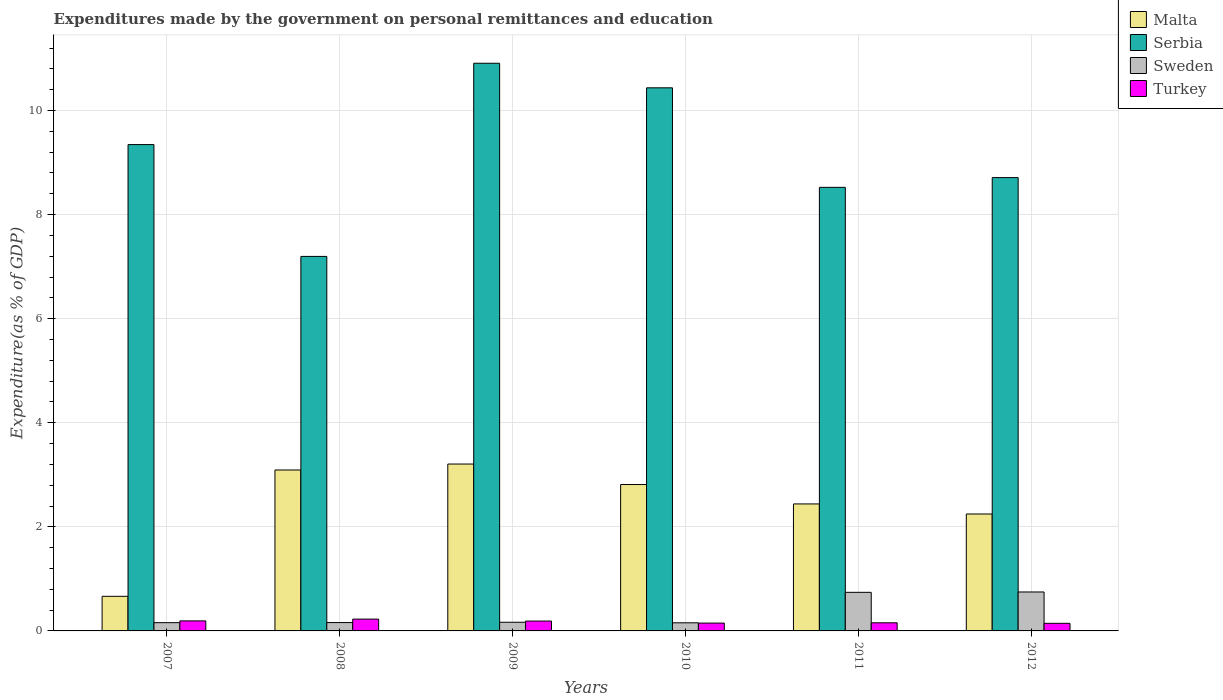How many different coloured bars are there?
Provide a short and direct response. 4. How many groups of bars are there?
Keep it short and to the point. 6. Are the number of bars per tick equal to the number of legend labels?
Your response must be concise. Yes. Are the number of bars on each tick of the X-axis equal?
Your answer should be very brief. Yes. How many bars are there on the 5th tick from the left?
Ensure brevity in your answer.  4. How many bars are there on the 1st tick from the right?
Offer a terse response. 4. What is the label of the 4th group of bars from the left?
Make the answer very short. 2010. In how many cases, is the number of bars for a given year not equal to the number of legend labels?
Your answer should be compact. 0. What is the expenditures made by the government on personal remittances and education in Turkey in 2011?
Make the answer very short. 0.16. Across all years, what is the maximum expenditures made by the government on personal remittances and education in Turkey?
Make the answer very short. 0.23. Across all years, what is the minimum expenditures made by the government on personal remittances and education in Malta?
Your answer should be compact. 0.66. In which year was the expenditures made by the government on personal remittances and education in Malta minimum?
Provide a succinct answer. 2007. What is the total expenditures made by the government on personal remittances and education in Malta in the graph?
Make the answer very short. 14.46. What is the difference between the expenditures made by the government on personal remittances and education in Serbia in 2009 and that in 2011?
Ensure brevity in your answer.  2.38. What is the difference between the expenditures made by the government on personal remittances and education in Turkey in 2011 and the expenditures made by the government on personal remittances and education in Sweden in 2010?
Ensure brevity in your answer.  0. What is the average expenditures made by the government on personal remittances and education in Malta per year?
Give a very brief answer. 2.41. In the year 2007, what is the difference between the expenditures made by the government on personal remittances and education in Turkey and expenditures made by the government on personal remittances and education in Sweden?
Give a very brief answer. 0.03. What is the ratio of the expenditures made by the government on personal remittances and education in Sweden in 2009 to that in 2012?
Offer a very short reply. 0.22. Is the difference between the expenditures made by the government on personal remittances and education in Turkey in 2007 and 2011 greater than the difference between the expenditures made by the government on personal remittances and education in Sweden in 2007 and 2011?
Make the answer very short. Yes. What is the difference between the highest and the second highest expenditures made by the government on personal remittances and education in Turkey?
Your answer should be very brief. 0.03. What is the difference between the highest and the lowest expenditures made by the government on personal remittances and education in Sweden?
Offer a very short reply. 0.59. What does the 2nd bar from the right in 2007 represents?
Make the answer very short. Sweden. Are all the bars in the graph horizontal?
Ensure brevity in your answer.  No. How many years are there in the graph?
Your answer should be very brief. 6. Does the graph contain grids?
Your answer should be very brief. Yes. Where does the legend appear in the graph?
Make the answer very short. Top right. How many legend labels are there?
Give a very brief answer. 4. What is the title of the graph?
Give a very brief answer. Expenditures made by the government on personal remittances and education. Does "Congo (Democratic)" appear as one of the legend labels in the graph?
Give a very brief answer. No. What is the label or title of the X-axis?
Offer a very short reply. Years. What is the label or title of the Y-axis?
Your response must be concise. Expenditure(as % of GDP). What is the Expenditure(as % of GDP) in Malta in 2007?
Provide a short and direct response. 0.66. What is the Expenditure(as % of GDP) in Serbia in 2007?
Your response must be concise. 9.34. What is the Expenditure(as % of GDP) of Sweden in 2007?
Your answer should be very brief. 0.16. What is the Expenditure(as % of GDP) of Turkey in 2007?
Give a very brief answer. 0.19. What is the Expenditure(as % of GDP) in Malta in 2008?
Your response must be concise. 3.09. What is the Expenditure(as % of GDP) of Serbia in 2008?
Keep it short and to the point. 7.2. What is the Expenditure(as % of GDP) in Sweden in 2008?
Keep it short and to the point. 0.16. What is the Expenditure(as % of GDP) of Turkey in 2008?
Offer a terse response. 0.23. What is the Expenditure(as % of GDP) in Malta in 2009?
Provide a short and direct response. 3.21. What is the Expenditure(as % of GDP) of Serbia in 2009?
Provide a succinct answer. 10.91. What is the Expenditure(as % of GDP) of Sweden in 2009?
Your answer should be very brief. 0.17. What is the Expenditure(as % of GDP) in Turkey in 2009?
Ensure brevity in your answer.  0.19. What is the Expenditure(as % of GDP) of Malta in 2010?
Give a very brief answer. 2.81. What is the Expenditure(as % of GDP) of Serbia in 2010?
Your response must be concise. 10.43. What is the Expenditure(as % of GDP) of Sweden in 2010?
Offer a very short reply. 0.16. What is the Expenditure(as % of GDP) in Turkey in 2010?
Keep it short and to the point. 0.15. What is the Expenditure(as % of GDP) of Malta in 2011?
Provide a short and direct response. 2.44. What is the Expenditure(as % of GDP) of Serbia in 2011?
Offer a terse response. 8.52. What is the Expenditure(as % of GDP) of Sweden in 2011?
Provide a succinct answer. 0.74. What is the Expenditure(as % of GDP) in Turkey in 2011?
Provide a short and direct response. 0.16. What is the Expenditure(as % of GDP) of Malta in 2012?
Provide a short and direct response. 2.25. What is the Expenditure(as % of GDP) in Serbia in 2012?
Ensure brevity in your answer.  8.71. What is the Expenditure(as % of GDP) in Sweden in 2012?
Provide a succinct answer. 0.75. What is the Expenditure(as % of GDP) in Turkey in 2012?
Give a very brief answer. 0.15. Across all years, what is the maximum Expenditure(as % of GDP) of Malta?
Offer a terse response. 3.21. Across all years, what is the maximum Expenditure(as % of GDP) of Serbia?
Offer a very short reply. 10.91. Across all years, what is the maximum Expenditure(as % of GDP) in Sweden?
Your answer should be very brief. 0.75. Across all years, what is the maximum Expenditure(as % of GDP) in Turkey?
Your response must be concise. 0.23. Across all years, what is the minimum Expenditure(as % of GDP) in Malta?
Provide a short and direct response. 0.66. Across all years, what is the minimum Expenditure(as % of GDP) in Serbia?
Give a very brief answer. 7.2. Across all years, what is the minimum Expenditure(as % of GDP) in Sweden?
Make the answer very short. 0.16. Across all years, what is the minimum Expenditure(as % of GDP) of Turkey?
Offer a very short reply. 0.15. What is the total Expenditure(as % of GDP) in Malta in the graph?
Offer a very short reply. 14.46. What is the total Expenditure(as % of GDP) of Serbia in the graph?
Your response must be concise. 55.11. What is the total Expenditure(as % of GDP) of Sweden in the graph?
Keep it short and to the point. 2.13. What is the total Expenditure(as % of GDP) of Turkey in the graph?
Offer a very short reply. 1.06. What is the difference between the Expenditure(as % of GDP) in Malta in 2007 and that in 2008?
Make the answer very short. -2.43. What is the difference between the Expenditure(as % of GDP) of Serbia in 2007 and that in 2008?
Offer a very short reply. 2.15. What is the difference between the Expenditure(as % of GDP) in Sweden in 2007 and that in 2008?
Provide a succinct answer. -0. What is the difference between the Expenditure(as % of GDP) in Turkey in 2007 and that in 2008?
Keep it short and to the point. -0.03. What is the difference between the Expenditure(as % of GDP) in Malta in 2007 and that in 2009?
Your answer should be very brief. -2.54. What is the difference between the Expenditure(as % of GDP) in Serbia in 2007 and that in 2009?
Keep it short and to the point. -1.56. What is the difference between the Expenditure(as % of GDP) in Sweden in 2007 and that in 2009?
Provide a short and direct response. -0.01. What is the difference between the Expenditure(as % of GDP) of Turkey in 2007 and that in 2009?
Make the answer very short. 0. What is the difference between the Expenditure(as % of GDP) of Malta in 2007 and that in 2010?
Your response must be concise. -2.15. What is the difference between the Expenditure(as % of GDP) of Serbia in 2007 and that in 2010?
Your answer should be compact. -1.09. What is the difference between the Expenditure(as % of GDP) of Sweden in 2007 and that in 2010?
Your response must be concise. 0. What is the difference between the Expenditure(as % of GDP) of Turkey in 2007 and that in 2010?
Make the answer very short. 0.04. What is the difference between the Expenditure(as % of GDP) in Malta in 2007 and that in 2011?
Your answer should be very brief. -1.77. What is the difference between the Expenditure(as % of GDP) of Serbia in 2007 and that in 2011?
Your answer should be very brief. 0.82. What is the difference between the Expenditure(as % of GDP) in Sweden in 2007 and that in 2011?
Provide a short and direct response. -0.58. What is the difference between the Expenditure(as % of GDP) in Turkey in 2007 and that in 2011?
Offer a terse response. 0.04. What is the difference between the Expenditure(as % of GDP) of Malta in 2007 and that in 2012?
Keep it short and to the point. -1.58. What is the difference between the Expenditure(as % of GDP) of Serbia in 2007 and that in 2012?
Your response must be concise. 0.63. What is the difference between the Expenditure(as % of GDP) in Sweden in 2007 and that in 2012?
Your response must be concise. -0.59. What is the difference between the Expenditure(as % of GDP) of Turkey in 2007 and that in 2012?
Provide a short and direct response. 0.05. What is the difference between the Expenditure(as % of GDP) of Malta in 2008 and that in 2009?
Offer a very short reply. -0.11. What is the difference between the Expenditure(as % of GDP) in Serbia in 2008 and that in 2009?
Provide a succinct answer. -3.71. What is the difference between the Expenditure(as % of GDP) of Sweden in 2008 and that in 2009?
Provide a succinct answer. -0.01. What is the difference between the Expenditure(as % of GDP) in Turkey in 2008 and that in 2009?
Offer a terse response. 0.04. What is the difference between the Expenditure(as % of GDP) of Malta in 2008 and that in 2010?
Provide a short and direct response. 0.28. What is the difference between the Expenditure(as % of GDP) of Serbia in 2008 and that in 2010?
Make the answer very short. -3.24. What is the difference between the Expenditure(as % of GDP) of Sweden in 2008 and that in 2010?
Offer a terse response. 0. What is the difference between the Expenditure(as % of GDP) of Turkey in 2008 and that in 2010?
Keep it short and to the point. 0.08. What is the difference between the Expenditure(as % of GDP) in Malta in 2008 and that in 2011?
Offer a very short reply. 0.65. What is the difference between the Expenditure(as % of GDP) in Serbia in 2008 and that in 2011?
Your answer should be compact. -1.33. What is the difference between the Expenditure(as % of GDP) in Sweden in 2008 and that in 2011?
Offer a very short reply. -0.58. What is the difference between the Expenditure(as % of GDP) in Turkey in 2008 and that in 2011?
Give a very brief answer. 0.07. What is the difference between the Expenditure(as % of GDP) of Malta in 2008 and that in 2012?
Your answer should be compact. 0.85. What is the difference between the Expenditure(as % of GDP) of Serbia in 2008 and that in 2012?
Give a very brief answer. -1.51. What is the difference between the Expenditure(as % of GDP) in Sweden in 2008 and that in 2012?
Give a very brief answer. -0.59. What is the difference between the Expenditure(as % of GDP) of Turkey in 2008 and that in 2012?
Give a very brief answer. 0.08. What is the difference between the Expenditure(as % of GDP) in Malta in 2009 and that in 2010?
Ensure brevity in your answer.  0.39. What is the difference between the Expenditure(as % of GDP) in Serbia in 2009 and that in 2010?
Provide a short and direct response. 0.47. What is the difference between the Expenditure(as % of GDP) of Sweden in 2009 and that in 2010?
Provide a short and direct response. 0.01. What is the difference between the Expenditure(as % of GDP) of Turkey in 2009 and that in 2010?
Ensure brevity in your answer.  0.04. What is the difference between the Expenditure(as % of GDP) of Malta in 2009 and that in 2011?
Make the answer very short. 0.77. What is the difference between the Expenditure(as % of GDP) in Serbia in 2009 and that in 2011?
Offer a very short reply. 2.38. What is the difference between the Expenditure(as % of GDP) of Sweden in 2009 and that in 2011?
Provide a short and direct response. -0.58. What is the difference between the Expenditure(as % of GDP) in Turkey in 2009 and that in 2011?
Offer a very short reply. 0.03. What is the difference between the Expenditure(as % of GDP) in Malta in 2009 and that in 2012?
Provide a short and direct response. 0.96. What is the difference between the Expenditure(as % of GDP) of Serbia in 2009 and that in 2012?
Your answer should be compact. 2.2. What is the difference between the Expenditure(as % of GDP) in Sweden in 2009 and that in 2012?
Your answer should be compact. -0.58. What is the difference between the Expenditure(as % of GDP) in Turkey in 2009 and that in 2012?
Make the answer very short. 0.04. What is the difference between the Expenditure(as % of GDP) in Malta in 2010 and that in 2011?
Make the answer very short. 0.37. What is the difference between the Expenditure(as % of GDP) in Serbia in 2010 and that in 2011?
Your answer should be very brief. 1.91. What is the difference between the Expenditure(as % of GDP) in Sweden in 2010 and that in 2011?
Provide a short and direct response. -0.59. What is the difference between the Expenditure(as % of GDP) in Turkey in 2010 and that in 2011?
Keep it short and to the point. -0.01. What is the difference between the Expenditure(as % of GDP) of Malta in 2010 and that in 2012?
Provide a short and direct response. 0.57. What is the difference between the Expenditure(as % of GDP) in Serbia in 2010 and that in 2012?
Give a very brief answer. 1.72. What is the difference between the Expenditure(as % of GDP) of Sweden in 2010 and that in 2012?
Your response must be concise. -0.59. What is the difference between the Expenditure(as % of GDP) of Turkey in 2010 and that in 2012?
Your answer should be compact. 0. What is the difference between the Expenditure(as % of GDP) of Malta in 2011 and that in 2012?
Offer a terse response. 0.19. What is the difference between the Expenditure(as % of GDP) in Serbia in 2011 and that in 2012?
Your response must be concise. -0.19. What is the difference between the Expenditure(as % of GDP) of Sweden in 2011 and that in 2012?
Make the answer very short. -0.01. What is the difference between the Expenditure(as % of GDP) of Turkey in 2011 and that in 2012?
Make the answer very short. 0.01. What is the difference between the Expenditure(as % of GDP) in Malta in 2007 and the Expenditure(as % of GDP) in Serbia in 2008?
Provide a succinct answer. -6.53. What is the difference between the Expenditure(as % of GDP) of Malta in 2007 and the Expenditure(as % of GDP) of Sweden in 2008?
Your answer should be compact. 0.5. What is the difference between the Expenditure(as % of GDP) in Malta in 2007 and the Expenditure(as % of GDP) in Turkey in 2008?
Your answer should be very brief. 0.44. What is the difference between the Expenditure(as % of GDP) in Serbia in 2007 and the Expenditure(as % of GDP) in Sweden in 2008?
Make the answer very short. 9.18. What is the difference between the Expenditure(as % of GDP) of Serbia in 2007 and the Expenditure(as % of GDP) of Turkey in 2008?
Your answer should be compact. 9.12. What is the difference between the Expenditure(as % of GDP) in Sweden in 2007 and the Expenditure(as % of GDP) in Turkey in 2008?
Make the answer very short. -0.07. What is the difference between the Expenditure(as % of GDP) of Malta in 2007 and the Expenditure(as % of GDP) of Serbia in 2009?
Your response must be concise. -10.24. What is the difference between the Expenditure(as % of GDP) of Malta in 2007 and the Expenditure(as % of GDP) of Sweden in 2009?
Your answer should be very brief. 0.5. What is the difference between the Expenditure(as % of GDP) in Malta in 2007 and the Expenditure(as % of GDP) in Turkey in 2009?
Ensure brevity in your answer.  0.48. What is the difference between the Expenditure(as % of GDP) in Serbia in 2007 and the Expenditure(as % of GDP) in Sweden in 2009?
Your response must be concise. 9.18. What is the difference between the Expenditure(as % of GDP) of Serbia in 2007 and the Expenditure(as % of GDP) of Turkey in 2009?
Your answer should be very brief. 9.15. What is the difference between the Expenditure(as % of GDP) in Sweden in 2007 and the Expenditure(as % of GDP) in Turkey in 2009?
Keep it short and to the point. -0.03. What is the difference between the Expenditure(as % of GDP) of Malta in 2007 and the Expenditure(as % of GDP) of Serbia in 2010?
Your answer should be very brief. -9.77. What is the difference between the Expenditure(as % of GDP) in Malta in 2007 and the Expenditure(as % of GDP) in Sweden in 2010?
Keep it short and to the point. 0.51. What is the difference between the Expenditure(as % of GDP) of Malta in 2007 and the Expenditure(as % of GDP) of Turkey in 2010?
Your response must be concise. 0.51. What is the difference between the Expenditure(as % of GDP) of Serbia in 2007 and the Expenditure(as % of GDP) of Sweden in 2010?
Your answer should be compact. 9.19. What is the difference between the Expenditure(as % of GDP) in Serbia in 2007 and the Expenditure(as % of GDP) in Turkey in 2010?
Provide a short and direct response. 9.19. What is the difference between the Expenditure(as % of GDP) of Sweden in 2007 and the Expenditure(as % of GDP) of Turkey in 2010?
Ensure brevity in your answer.  0.01. What is the difference between the Expenditure(as % of GDP) in Malta in 2007 and the Expenditure(as % of GDP) in Serbia in 2011?
Keep it short and to the point. -7.86. What is the difference between the Expenditure(as % of GDP) in Malta in 2007 and the Expenditure(as % of GDP) in Sweden in 2011?
Offer a very short reply. -0.08. What is the difference between the Expenditure(as % of GDP) in Malta in 2007 and the Expenditure(as % of GDP) in Turkey in 2011?
Keep it short and to the point. 0.51. What is the difference between the Expenditure(as % of GDP) in Serbia in 2007 and the Expenditure(as % of GDP) in Sweden in 2011?
Provide a succinct answer. 8.6. What is the difference between the Expenditure(as % of GDP) of Serbia in 2007 and the Expenditure(as % of GDP) of Turkey in 2011?
Give a very brief answer. 9.19. What is the difference between the Expenditure(as % of GDP) of Sweden in 2007 and the Expenditure(as % of GDP) of Turkey in 2011?
Offer a terse response. 0. What is the difference between the Expenditure(as % of GDP) in Malta in 2007 and the Expenditure(as % of GDP) in Serbia in 2012?
Make the answer very short. -8.04. What is the difference between the Expenditure(as % of GDP) of Malta in 2007 and the Expenditure(as % of GDP) of Sweden in 2012?
Give a very brief answer. -0.08. What is the difference between the Expenditure(as % of GDP) of Malta in 2007 and the Expenditure(as % of GDP) of Turkey in 2012?
Provide a succinct answer. 0.52. What is the difference between the Expenditure(as % of GDP) in Serbia in 2007 and the Expenditure(as % of GDP) in Sweden in 2012?
Keep it short and to the point. 8.6. What is the difference between the Expenditure(as % of GDP) in Serbia in 2007 and the Expenditure(as % of GDP) in Turkey in 2012?
Provide a succinct answer. 9.2. What is the difference between the Expenditure(as % of GDP) in Sweden in 2007 and the Expenditure(as % of GDP) in Turkey in 2012?
Keep it short and to the point. 0.01. What is the difference between the Expenditure(as % of GDP) in Malta in 2008 and the Expenditure(as % of GDP) in Serbia in 2009?
Offer a terse response. -7.82. What is the difference between the Expenditure(as % of GDP) in Malta in 2008 and the Expenditure(as % of GDP) in Sweden in 2009?
Offer a terse response. 2.93. What is the difference between the Expenditure(as % of GDP) in Malta in 2008 and the Expenditure(as % of GDP) in Turkey in 2009?
Give a very brief answer. 2.9. What is the difference between the Expenditure(as % of GDP) of Serbia in 2008 and the Expenditure(as % of GDP) of Sweden in 2009?
Keep it short and to the point. 7.03. What is the difference between the Expenditure(as % of GDP) in Serbia in 2008 and the Expenditure(as % of GDP) in Turkey in 2009?
Offer a very short reply. 7.01. What is the difference between the Expenditure(as % of GDP) of Sweden in 2008 and the Expenditure(as % of GDP) of Turkey in 2009?
Your response must be concise. -0.03. What is the difference between the Expenditure(as % of GDP) in Malta in 2008 and the Expenditure(as % of GDP) in Serbia in 2010?
Offer a terse response. -7.34. What is the difference between the Expenditure(as % of GDP) in Malta in 2008 and the Expenditure(as % of GDP) in Sweden in 2010?
Offer a very short reply. 2.94. What is the difference between the Expenditure(as % of GDP) in Malta in 2008 and the Expenditure(as % of GDP) in Turkey in 2010?
Provide a short and direct response. 2.94. What is the difference between the Expenditure(as % of GDP) in Serbia in 2008 and the Expenditure(as % of GDP) in Sweden in 2010?
Give a very brief answer. 7.04. What is the difference between the Expenditure(as % of GDP) of Serbia in 2008 and the Expenditure(as % of GDP) of Turkey in 2010?
Offer a very short reply. 7.05. What is the difference between the Expenditure(as % of GDP) in Malta in 2008 and the Expenditure(as % of GDP) in Serbia in 2011?
Your answer should be compact. -5.43. What is the difference between the Expenditure(as % of GDP) of Malta in 2008 and the Expenditure(as % of GDP) of Sweden in 2011?
Provide a succinct answer. 2.35. What is the difference between the Expenditure(as % of GDP) in Malta in 2008 and the Expenditure(as % of GDP) in Turkey in 2011?
Your response must be concise. 2.94. What is the difference between the Expenditure(as % of GDP) in Serbia in 2008 and the Expenditure(as % of GDP) in Sweden in 2011?
Give a very brief answer. 6.45. What is the difference between the Expenditure(as % of GDP) in Serbia in 2008 and the Expenditure(as % of GDP) in Turkey in 2011?
Make the answer very short. 7.04. What is the difference between the Expenditure(as % of GDP) of Sweden in 2008 and the Expenditure(as % of GDP) of Turkey in 2011?
Your answer should be very brief. 0. What is the difference between the Expenditure(as % of GDP) in Malta in 2008 and the Expenditure(as % of GDP) in Serbia in 2012?
Make the answer very short. -5.62. What is the difference between the Expenditure(as % of GDP) of Malta in 2008 and the Expenditure(as % of GDP) of Sweden in 2012?
Your answer should be compact. 2.34. What is the difference between the Expenditure(as % of GDP) in Malta in 2008 and the Expenditure(as % of GDP) in Turkey in 2012?
Keep it short and to the point. 2.95. What is the difference between the Expenditure(as % of GDP) of Serbia in 2008 and the Expenditure(as % of GDP) of Sweden in 2012?
Keep it short and to the point. 6.45. What is the difference between the Expenditure(as % of GDP) in Serbia in 2008 and the Expenditure(as % of GDP) in Turkey in 2012?
Make the answer very short. 7.05. What is the difference between the Expenditure(as % of GDP) in Sweden in 2008 and the Expenditure(as % of GDP) in Turkey in 2012?
Keep it short and to the point. 0.01. What is the difference between the Expenditure(as % of GDP) of Malta in 2009 and the Expenditure(as % of GDP) of Serbia in 2010?
Provide a short and direct response. -7.23. What is the difference between the Expenditure(as % of GDP) of Malta in 2009 and the Expenditure(as % of GDP) of Sweden in 2010?
Give a very brief answer. 3.05. What is the difference between the Expenditure(as % of GDP) in Malta in 2009 and the Expenditure(as % of GDP) in Turkey in 2010?
Provide a short and direct response. 3.06. What is the difference between the Expenditure(as % of GDP) in Serbia in 2009 and the Expenditure(as % of GDP) in Sweden in 2010?
Give a very brief answer. 10.75. What is the difference between the Expenditure(as % of GDP) of Serbia in 2009 and the Expenditure(as % of GDP) of Turkey in 2010?
Make the answer very short. 10.76. What is the difference between the Expenditure(as % of GDP) of Sweden in 2009 and the Expenditure(as % of GDP) of Turkey in 2010?
Offer a very short reply. 0.02. What is the difference between the Expenditure(as % of GDP) of Malta in 2009 and the Expenditure(as % of GDP) of Serbia in 2011?
Keep it short and to the point. -5.32. What is the difference between the Expenditure(as % of GDP) of Malta in 2009 and the Expenditure(as % of GDP) of Sweden in 2011?
Make the answer very short. 2.46. What is the difference between the Expenditure(as % of GDP) of Malta in 2009 and the Expenditure(as % of GDP) of Turkey in 2011?
Make the answer very short. 3.05. What is the difference between the Expenditure(as % of GDP) in Serbia in 2009 and the Expenditure(as % of GDP) in Sweden in 2011?
Offer a terse response. 10.17. What is the difference between the Expenditure(as % of GDP) in Serbia in 2009 and the Expenditure(as % of GDP) in Turkey in 2011?
Offer a very short reply. 10.75. What is the difference between the Expenditure(as % of GDP) of Sweden in 2009 and the Expenditure(as % of GDP) of Turkey in 2011?
Your response must be concise. 0.01. What is the difference between the Expenditure(as % of GDP) in Malta in 2009 and the Expenditure(as % of GDP) in Serbia in 2012?
Offer a very short reply. -5.5. What is the difference between the Expenditure(as % of GDP) in Malta in 2009 and the Expenditure(as % of GDP) in Sweden in 2012?
Keep it short and to the point. 2.46. What is the difference between the Expenditure(as % of GDP) in Malta in 2009 and the Expenditure(as % of GDP) in Turkey in 2012?
Keep it short and to the point. 3.06. What is the difference between the Expenditure(as % of GDP) of Serbia in 2009 and the Expenditure(as % of GDP) of Sweden in 2012?
Your response must be concise. 10.16. What is the difference between the Expenditure(as % of GDP) of Serbia in 2009 and the Expenditure(as % of GDP) of Turkey in 2012?
Provide a short and direct response. 10.76. What is the difference between the Expenditure(as % of GDP) in Sweden in 2009 and the Expenditure(as % of GDP) in Turkey in 2012?
Your response must be concise. 0.02. What is the difference between the Expenditure(as % of GDP) of Malta in 2010 and the Expenditure(as % of GDP) of Serbia in 2011?
Offer a very short reply. -5.71. What is the difference between the Expenditure(as % of GDP) of Malta in 2010 and the Expenditure(as % of GDP) of Sweden in 2011?
Offer a terse response. 2.07. What is the difference between the Expenditure(as % of GDP) in Malta in 2010 and the Expenditure(as % of GDP) in Turkey in 2011?
Keep it short and to the point. 2.66. What is the difference between the Expenditure(as % of GDP) in Serbia in 2010 and the Expenditure(as % of GDP) in Sweden in 2011?
Ensure brevity in your answer.  9.69. What is the difference between the Expenditure(as % of GDP) in Serbia in 2010 and the Expenditure(as % of GDP) in Turkey in 2011?
Offer a terse response. 10.28. What is the difference between the Expenditure(as % of GDP) of Sweden in 2010 and the Expenditure(as % of GDP) of Turkey in 2011?
Provide a short and direct response. -0. What is the difference between the Expenditure(as % of GDP) in Malta in 2010 and the Expenditure(as % of GDP) in Serbia in 2012?
Offer a terse response. -5.9. What is the difference between the Expenditure(as % of GDP) of Malta in 2010 and the Expenditure(as % of GDP) of Sweden in 2012?
Offer a terse response. 2.06. What is the difference between the Expenditure(as % of GDP) of Malta in 2010 and the Expenditure(as % of GDP) of Turkey in 2012?
Keep it short and to the point. 2.67. What is the difference between the Expenditure(as % of GDP) of Serbia in 2010 and the Expenditure(as % of GDP) of Sweden in 2012?
Give a very brief answer. 9.69. What is the difference between the Expenditure(as % of GDP) of Serbia in 2010 and the Expenditure(as % of GDP) of Turkey in 2012?
Provide a succinct answer. 10.29. What is the difference between the Expenditure(as % of GDP) in Sweden in 2010 and the Expenditure(as % of GDP) in Turkey in 2012?
Provide a short and direct response. 0.01. What is the difference between the Expenditure(as % of GDP) in Malta in 2011 and the Expenditure(as % of GDP) in Serbia in 2012?
Give a very brief answer. -6.27. What is the difference between the Expenditure(as % of GDP) in Malta in 2011 and the Expenditure(as % of GDP) in Sweden in 2012?
Offer a terse response. 1.69. What is the difference between the Expenditure(as % of GDP) in Malta in 2011 and the Expenditure(as % of GDP) in Turkey in 2012?
Ensure brevity in your answer.  2.29. What is the difference between the Expenditure(as % of GDP) in Serbia in 2011 and the Expenditure(as % of GDP) in Sweden in 2012?
Make the answer very short. 7.77. What is the difference between the Expenditure(as % of GDP) of Serbia in 2011 and the Expenditure(as % of GDP) of Turkey in 2012?
Offer a very short reply. 8.38. What is the difference between the Expenditure(as % of GDP) of Sweden in 2011 and the Expenditure(as % of GDP) of Turkey in 2012?
Provide a short and direct response. 0.6. What is the average Expenditure(as % of GDP) of Malta per year?
Keep it short and to the point. 2.41. What is the average Expenditure(as % of GDP) in Serbia per year?
Your answer should be compact. 9.19. What is the average Expenditure(as % of GDP) of Sweden per year?
Make the answer very short. 0.36. What is the average Expenditure(as % of GDP) of Turkey per year?
Make the answer very short. 0.18. In the year 2007, what is the difference between the Expenditure(as % of GDP) in Malta and Expenditure(as % of GDP) in Serbia?
Keep it short and to the point. -8.68. In the year 2007, what is the difference between the Expenditure(as % of GDP) of Malta and Expenditure(as % of GDP) of Sweden?
Your answer should be compact. 0.51. In the year 2007, what is the difference between the Expenditure(as % of GDP) in Malta and Expenditure(as % of GDP) in Turkey?
Offer a terse response. 0.47. In the year 2007, what is the difference between the Expenditure(as % of GDP) of Serbia and Expenditure(as % of GDP) of Sweden?
Provide a short and direct response. 9.19. In the year 2007, what is the difference between the Expenditure(as % of GDP) of Serbia and Expenditure(as % of GDP) of Turkey?
Your response must be concise. 9.15. In the year 2007, what is the difference between the Expenditure(as % of GDP) in Sweden and Expenditure(as % of GDP) in Turkey?
Provide a succinct answer. -0.03. In the year 2008, what is the difference between the Expenditure(as % of GDP) of Malta and Expenditure(as % of GDP) of Serbia?
Provide a succinct answer. -4.1. In the year 2008, what is the difference between the Expenditure(as % of GDP) in Malta and Expenditure(as % of GDP) in Sweden?
Provide a short and direct response. 2.93. In the year 2008, what is the difference between the Expenditure(as % of GDP) in Malta and Expenditure(as % of GDP) in Turkey?
Give a very brief answer. 2.86. In the year 2008, what is the difference between the Expenditure(as % of GDP) of Serbia and Expenditure(as % of GDP) of Sweden?
Provide a succinct answer. 7.04. In the year 2008, what is the difference between the Expenditure(as % of GDP) of Serbia and Expenditure(as % of GDP) of Turkey?
Your answer should be compact. 6.97. In the year 2008, what is the difference between the Expenditure(as % of GDP) in Sweden and Expenditure(as % of GDP) in Turkey?
Provide a short and direct response. -0.07. In the year 2009, what is the difference between the Expenditure(as % of GDP) of Malta and Expenditure(as % of GDP) of Serbia?
Make the answer very short. -7.7. In the year 2009, what is the difference between the Expenditure(as % of GDP) of Malta and Expenditure(as % of GDP) of Sweden?
Provide a succinct answer. 3.04. In the year 2009, what is the difference between the Expenditure(as % of GDP) in Malta and Expenditure(as % of GDP) in Turkey?
Make the answer very short. 3.02. In the year 2009, what is the difference between the Expenditure(as % of GDP) of Serbia and Expenditure(as % of GDP) of Sweden?
Ensure brevity in your answer.  10.74. In the year 2009, what is the difference between the Expenditure(as % of GDP) of Serbia and Expenditure(as % of GDP) of Turkey?
Your answer should be compact. 10.72. In the year 2009, what is the difference between the Expenditure(as % of GDP) of Sweden and Expenditure(as % of GDP) of Turkey?
Your response must be concise. -0.02. In the year 2010, what is the difference between the Expenditure(as % of GDP) in Malta and Expenditure(as % of GDP) in Serbia?
Your answer should be compact. -7.62. In the year 2010, what is the difference between the Expenditure(as % of GDP) in Malta and Expenditure(as % of GDP) in Sweden?
Offer a very short reply. 2.66. In the year 2010, what is the difference between the Expenditure(as % of GDP) in Malta and Expenditure(as % of GDP) in Turkey?
Keep it short and to the point. 2.66. In the year 2010, what is the difference between the Expenditure(as % of GDP) of Serbia and Expenditure(as % of GDP) of Sweden?
Keep it short and to the point. 10.28. In the year 2010, what is the difference between the Expenditure(as % of GDP) of Serbia and Expenditure(as % of GDP) of Turkey?
Keep it short and to the point. 10.28. In the year 2010, what is the difference between the Expenditure(as % of GDP) in Sweden and Expenditure(as % of GDP) in Turkey?
Your answer should be very brief. 0.01. In the year 2011, what is the difference between the Expenditure(as % of GDP) of Malta and Expenditure(as % of GDP) of Serbia?
Your answer should be very brief. -6.08. In the year 2011, what is the difference between the Expenditure(as % of GDP) of Malta and Expenditure(as % of GDP) of Sweden?
Your response must be concise. 1.7. In the year 2011, what is the difference between the Expenditure(as % of GDP) of Malta and Expenditure(as % of GDP) of Turkey?
Provide a short and direct response. 2.28. In the year 2011, what is the difference between the Expenditure(as % of GDP) of Serbia and Expenditure(as % of GDP) of Sweden?
Give a very brief answer. 7.78. In the year 2011, what is the difference between the Expenditure(as % of GDP) in Serbia and Expenditure(as % of GDP) in Turkey?
Ensure brevity in your answer.  8.37. In the year 2011, what is the difference between the Expenditure(as % of GDP) of Sweden and Expenditure(as % of GDP) of Turkey?
Your answer should be very brief. 0.59. In the year 2012, what is the difference between the Expenditure(as % of GDP) of Malta and Expenditure(as % of GDP) of Serbia?
Make the answer very short. -6.46. In the year 2012, what is the difference between the Expenditure(as % of GDP) in Malta and Expenditure(as % of GDP) in Sweden?
Your response must be concise. 1.5. In the year 2012, what is the difference between the Expenditure(as % of GDP) of Malta and Expenditure(as % of GDP) of Turkey?
Provide a short and direct response. 2.1. In the year 2012, what is the difference between the Expenditure(as % of GDP) of Serbia and Expenditure(as % of GDP) of Sweden?
Give a very brief answer. 7.96. In the year 2012, what is the difference between the Expenditure(as % of GDP) of Serbia and Expenditure(as % of GDP) of Turkey?
Your answer should be compact. 8.56. In the year 2012, what is the difference between the Expenditure(as % of GDP) in Sweden and Expenditure(as % of GDP) in Turkey?
Make the answer very short. 0.6. What is the ratio of the Expenditure(as % of GDP) of Malta in 2007 to that in 2008?
Keep it short and to the point. 0.22. What is the ratio of the Expenditure(as % of GDP) in Serbia in 2007 to that in 2008?
Provide a succinct answer. 1.3. What is the ratio of the Expenditure(as % of GDP) in Sweden in 2007 to that in 2008?
Give a very brief answer. 0.99. What is the ratio of the Expenditure(as % of GDP) of Turkey in 2007 to that in 2008?
Provide a short and direct response. 0.85. What is the ratio of the Expenditure(as % of GDP) in Malta in 2007 to that in 2009?
Offer a terse response. 0.21. What is the ratio of the Expenditure(as % of GDP) in Serbia in 2007 to that in 2009?
Keep it short and to the point. 0.86. What is the ratio of the Expenditure(as % of GDP) in Sweden in 2007 to that in 2009?
Your answer should be compact. 0.95. What is the ratio of the Expenditure(as % of GDP) in Turkey in 2007 to that in 2009?
Ensure brevity in your answer.  1.02. What is the ratio of the Expenditure(as % of GDP) in Malta in 2007 to that in 2010?
Provide a succinct answer. 0.24. What is the ratio of the Expenditure(as % of GDP) in Serbia in 2007 to that in 2010?
Keep it short and to the point. 0.9. What is the ratio of the Expenditure(as % of GDP) of Sweden in 2007 to that in 2010?
Your answer should be compact. 1.02. What is the ratio of the Expenditure(as % of GDP) in Turkey in 2007 to that in 2010?
Your answer should be very brief. 1.28. What is the ratio of the Expenditure(as % of GDP) in Malta in 2007 to that in 2011?
Offer a very short reply. 0.27. What is the ratio of the Expenditure(as % of GDP) of Serbia in 2007 to that in 2011?
Your answer should be compact. 1.1. What is the ratio of the Expenditure(as % of GDP) of Sweden in 2007 to that in 2011?
Ensure brevity in your answer.  0.21. What is the ratio of the Expenditure(as % of GDP) in Turkey in 2007 to that in 2011?
Keep it short and to the point. 1.23. What is the ratio of the Expenditure(as % of GDP) of Malta in 2007 to that in 2012?
Your answer should be very brief. 0.3. What is the ratio of the Expenditure(as % of GDP) of Serbia in 2007 to that in 2012?
Offer a very short reply. 1.07. What is the ratio of the Expenditure(as % of GDP) of Sweden in 2007 to that in 2012?
Make the answer very short. 0.21. What is the ratio of the Expenditure(as % of GDP) in Turkey in 2007 to that in 2012?
Give a very brief answer. 1.32. What is the ratio of the Expenditure(as % of GDP) of Malta in 2008 to that in 2009?
Your answer should be very brief. 0.96. What is the ratio of the Expenditure(as % of GDP) in Serbia in 2008 to that in 2009?
Your answer should be compact. 0.66. What is the ratio of the Expenditure(as % of GDP) of Sweden in 2008 to that in 2009?
Provide a short and direct response. 0.96. What is the ratio of the Expenditure(as % of GDP) in Turkey in 2008 to that in 2009?
Keep it short and to the point. 1.2. What is the ratio of the Expenditure(as % of GDP) in Malta in 2008 to that in 2010?
Offer a very short reply. 1.1. What is the ratio of the Expenditure(as % of GDP) in Serbia in 2008 to that in 2010?
Make the answer very short. 0.69. What is the ratio of the Expenditure(as % of GDP) in Sweden in 2008 to that in 2010?
Offer a very short reply. 1.03. What is the ratio of the Expenditure(as % of GDP) in Turkey in 2008 to that in 2010?
Offer a terse response. 1.51. What is the ratio of the Expenditure(as % of GDP) in Malta in 2008 to that in 2011?
Give a very brief answer. 1.27. What is the ratio of the Expenditure(as % of GDP) in Serbia in 2008 to that in 2011?
Your answer should be compact. 0.84. What is the ratio of the Expenditure(as % of GDP) of Sweden in 2008 to that in 2011?
Make the answer very short. 0.22. What is the ratio of the Expenditure(as % of GDP) in Turkey in 2008 to that in 2011?
Keep it short and to the point. 1.45. What is the ratio of the Expenditure(as % of GDP) of Malta in 2008 to that in 2012?
Provide a succinct answer. 1.38. What is the ratio of the Expenditure(as % of GDP) in Serbia in 2008 to that in 2012?
Ensure brevity in your answer.  0.83. What is the ratio of the Expenditure(as % of GDP) of Sweden in 2008 to that in 2012?
Your response must be concise. 0.21. What is the ratio of the Expenditure(as % of GDP) in Turkey in 2008 to that in 2012?
Keep it short and to the point. 1.55. What is the ratio of the Expenditure(as % of GDP) of Malta in 2009 to that in 2010?
Your answer should be compact. 1.14. What is the ratio of the Expenditure(as % of GDP) in Serbia in 2009 to that in 2010?
Offer a very short reply. 1.05. What is the ratio of the Expenditure(as % of GDP) in Sweden in 2009 to that in 2010?
Offer a very short reply. 1.07. What is the ratio of the Expenditure(as % of GDP) of Turkey in 2009 to that in 2010?
Provide a short and direct response. 1.26. What is the ratio of the Expenditure(as % of GDP) of Malta in 2009 to that in 2011?
Offer a terse response. 1.31. What is the ratio of the Expenditure(as % of GDP) in Serbia in 2009 to that in 2011?
Keep it short and to the point. 1.28. What is the ratio of the Expenditure(as % of GDP) of Sweden in 2009 to that in 2011?
Make the answer very short. 0.22. What is the ratio of the Expenditure(as % of GDP) of Turkey in 2009 to that in 2011?
Your answer should be compact. 1.21. What is the ratio of the Expenditure(as % of GDP) in Malta in 2009 to that in 2012?
Ensure brevity in your answer.  1.43. What is the ratio of the Expenditure(as % of GDP) in Serbia in 2009 to that in 2012?
Provide a short and direct response. 1.25. What is the ratio of the Expenditure(as % of GDP) of Sweden in 2009 to that in 2012?
Your answer should be very brief. 0.22. What is the ratio of the Expenditure(as % of GDP) of Turkey in 2009 to that in 2012?
Keep it short and to the point. 1.3. What is the ratio of the Expenditure(as % of GDP) in Malta in 2010 to that in 2011?
Ensure brevity in your answer.  1.15. What is the ratio of the Expenditure(as % of GDP) in Serbia in 2010 to that in 2011?
Your answer should be compact. 1.22. What is the ratio of the Expenditure(as % of GDP) of Sweden in 2010 to that in 2011?
Provide a short and direct response. 0.21. What is the ratio of the Expenditure(as % of GDP) of Turkey in 2010 to that in 2011?
Your answer should be very brief. 0.96. What is the ratio of the Expenditure(as % of GDP) in Malta in 2010 to that in 2012?
Give a very brief answer. 1.25. What is the ratio of the Expenditure(as % of GDP) of Serbia in 2010 to that in 2012?
Offer a terse response. 1.2. What is the ratio of the Expenditure(as % of GDP) of Sweden in 2010 to that in 2012?
Provide a succinct answer. 0.21. What is the ratio of the Expenditure(as % of GDP) in Turkey in 2010 to that in 2012?
Give a very brief answer. 1.03. What is the ratio of the Expenditure(as % of GDP) of Malta in 2011 to that in 2012?
Ensure brevity in your answer.  1.09. What is the ratio of the Expenditure(as % of GDP) of Serbia in 2011 to that in 2012?
Give a very brief answer. 0.98. What is the ratio of the Expenditure(as % of GDP) in Sweden in 2011 to that in 2012?
Your answer should be very brief. 0.99. What is the ratio of the Expenditure(as % of GDP) in Turkey in 2011 to that in 2012?
Make the answer very short. 1.07. What is the difference between the highest and the second highest Expenditure(as % of GDP) in Malta?
Your answer should be very brief. 0.11. What is the difference between the highest and the second highest Expenditure(as % of GDP) in Serbia?
Provide a succinct answer. 0.47. What is the difference between the highest and the second highest Expenditure(as % of GDP) of Sweden?
Ensure brevity in your answer.  0.01. What is the difference between the highest and the second highest Expenditure(as % of GDP) in Turkey?
Give a very brief answer. 0.03. What is the difference between the highest and the lowest Expenditure(as % of GDP) of Malta?
Your response must be concise. 2.54. What is the difference between the highest and the lowest Expenditure(as % of GDP) of Serbia?
Give a very brief answer. 3.71. What is the difference between the highest and the lowest Expenditure(as % of GDP) of Sweden?
Keep it short and to the point. 0.59. What is the difference between the highest and the lowest Expenditure(as % of GDP) of Turkey?
Provide a short and direct response. 0.08. 